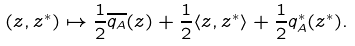Convert formula to latex. <formula><loc_0><loc_0><loc_500><loc_500>( z , z ^ { * } ) \mapsto \frac { 1 } { 2 } \overline { q _ { A } } ( z ) + \frac { 1 } { 2 } \langle z , z ^ { * } \rangle + \frac { 1 } { 2 } q ^ { * } _ { A } ( z ^ { * } ) .</formula> 